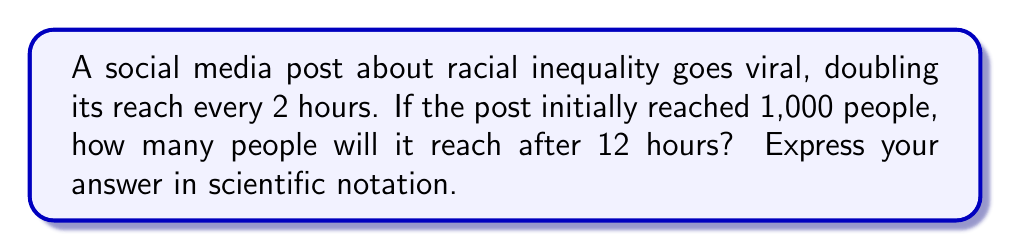Can you solve this math problem? Let's approach this step-by-step:

1) First, we need to determine how many times the post's reach doubles in 12 hours:
   12 hours ÷ 2 hours per doubling = 6 doublings

2) We can express this as an exponential equation:
   $$ 1,000 \times 2^6 $$

3) Let's calculate $2^6$:
   $$ 2^6 = 2 \times 2 \times 2 \times 2 \times 2 \times 2 = 64 $$

4) Now, we multiply the initial reach by this factor:
   $$ 1,000 \times 64 = 64,000 $$

5) To express this in scientific notation, we move the decimal point 4 places to the left:
   $$ 64,000 = 6.4 \times 10^4 $$

Thus, after 12 hours, the post will reach $6.4 \times 10^4$ people.
Answer: $6.4 \times 10^4$ 